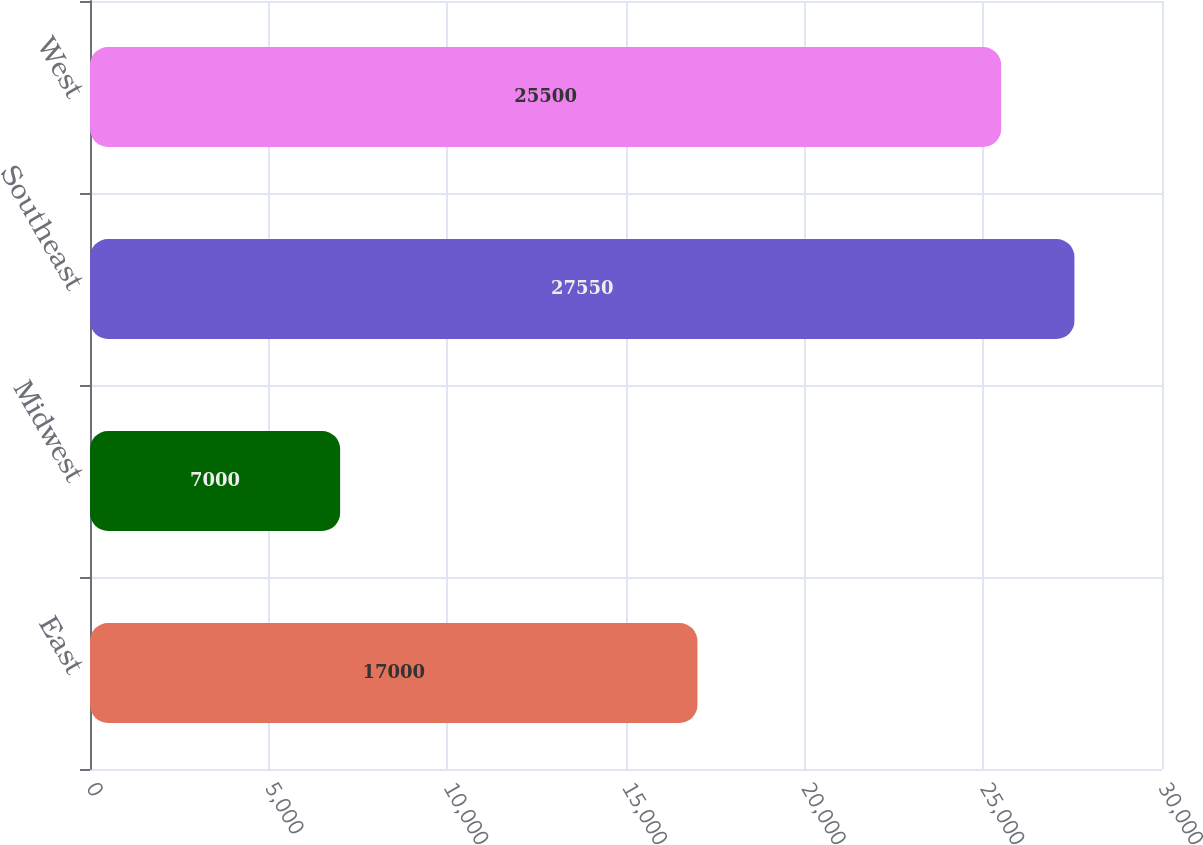<chart> <loc_0><loc_0><loc_500><loc_500><bar_chart><fcel>East<fcel>Midwest<fcel>Southeast<fcel>West<nl><fcel>17000<fcel>7000<fcel>27550<fcel>25500<nl></chart> 